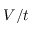<formula> <loc_0><loc_0><loc_500><loc_500>V / t</formula> 